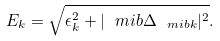<formula> <loc_0><loc_0><loc_500><loc_500>E _ { k } = \sqrt { \epsilon _ { k } ^ { 2 } + | \ m i b { \Delta } _ { \ m i b { k } } | ^ { 2 } } .</formula> 